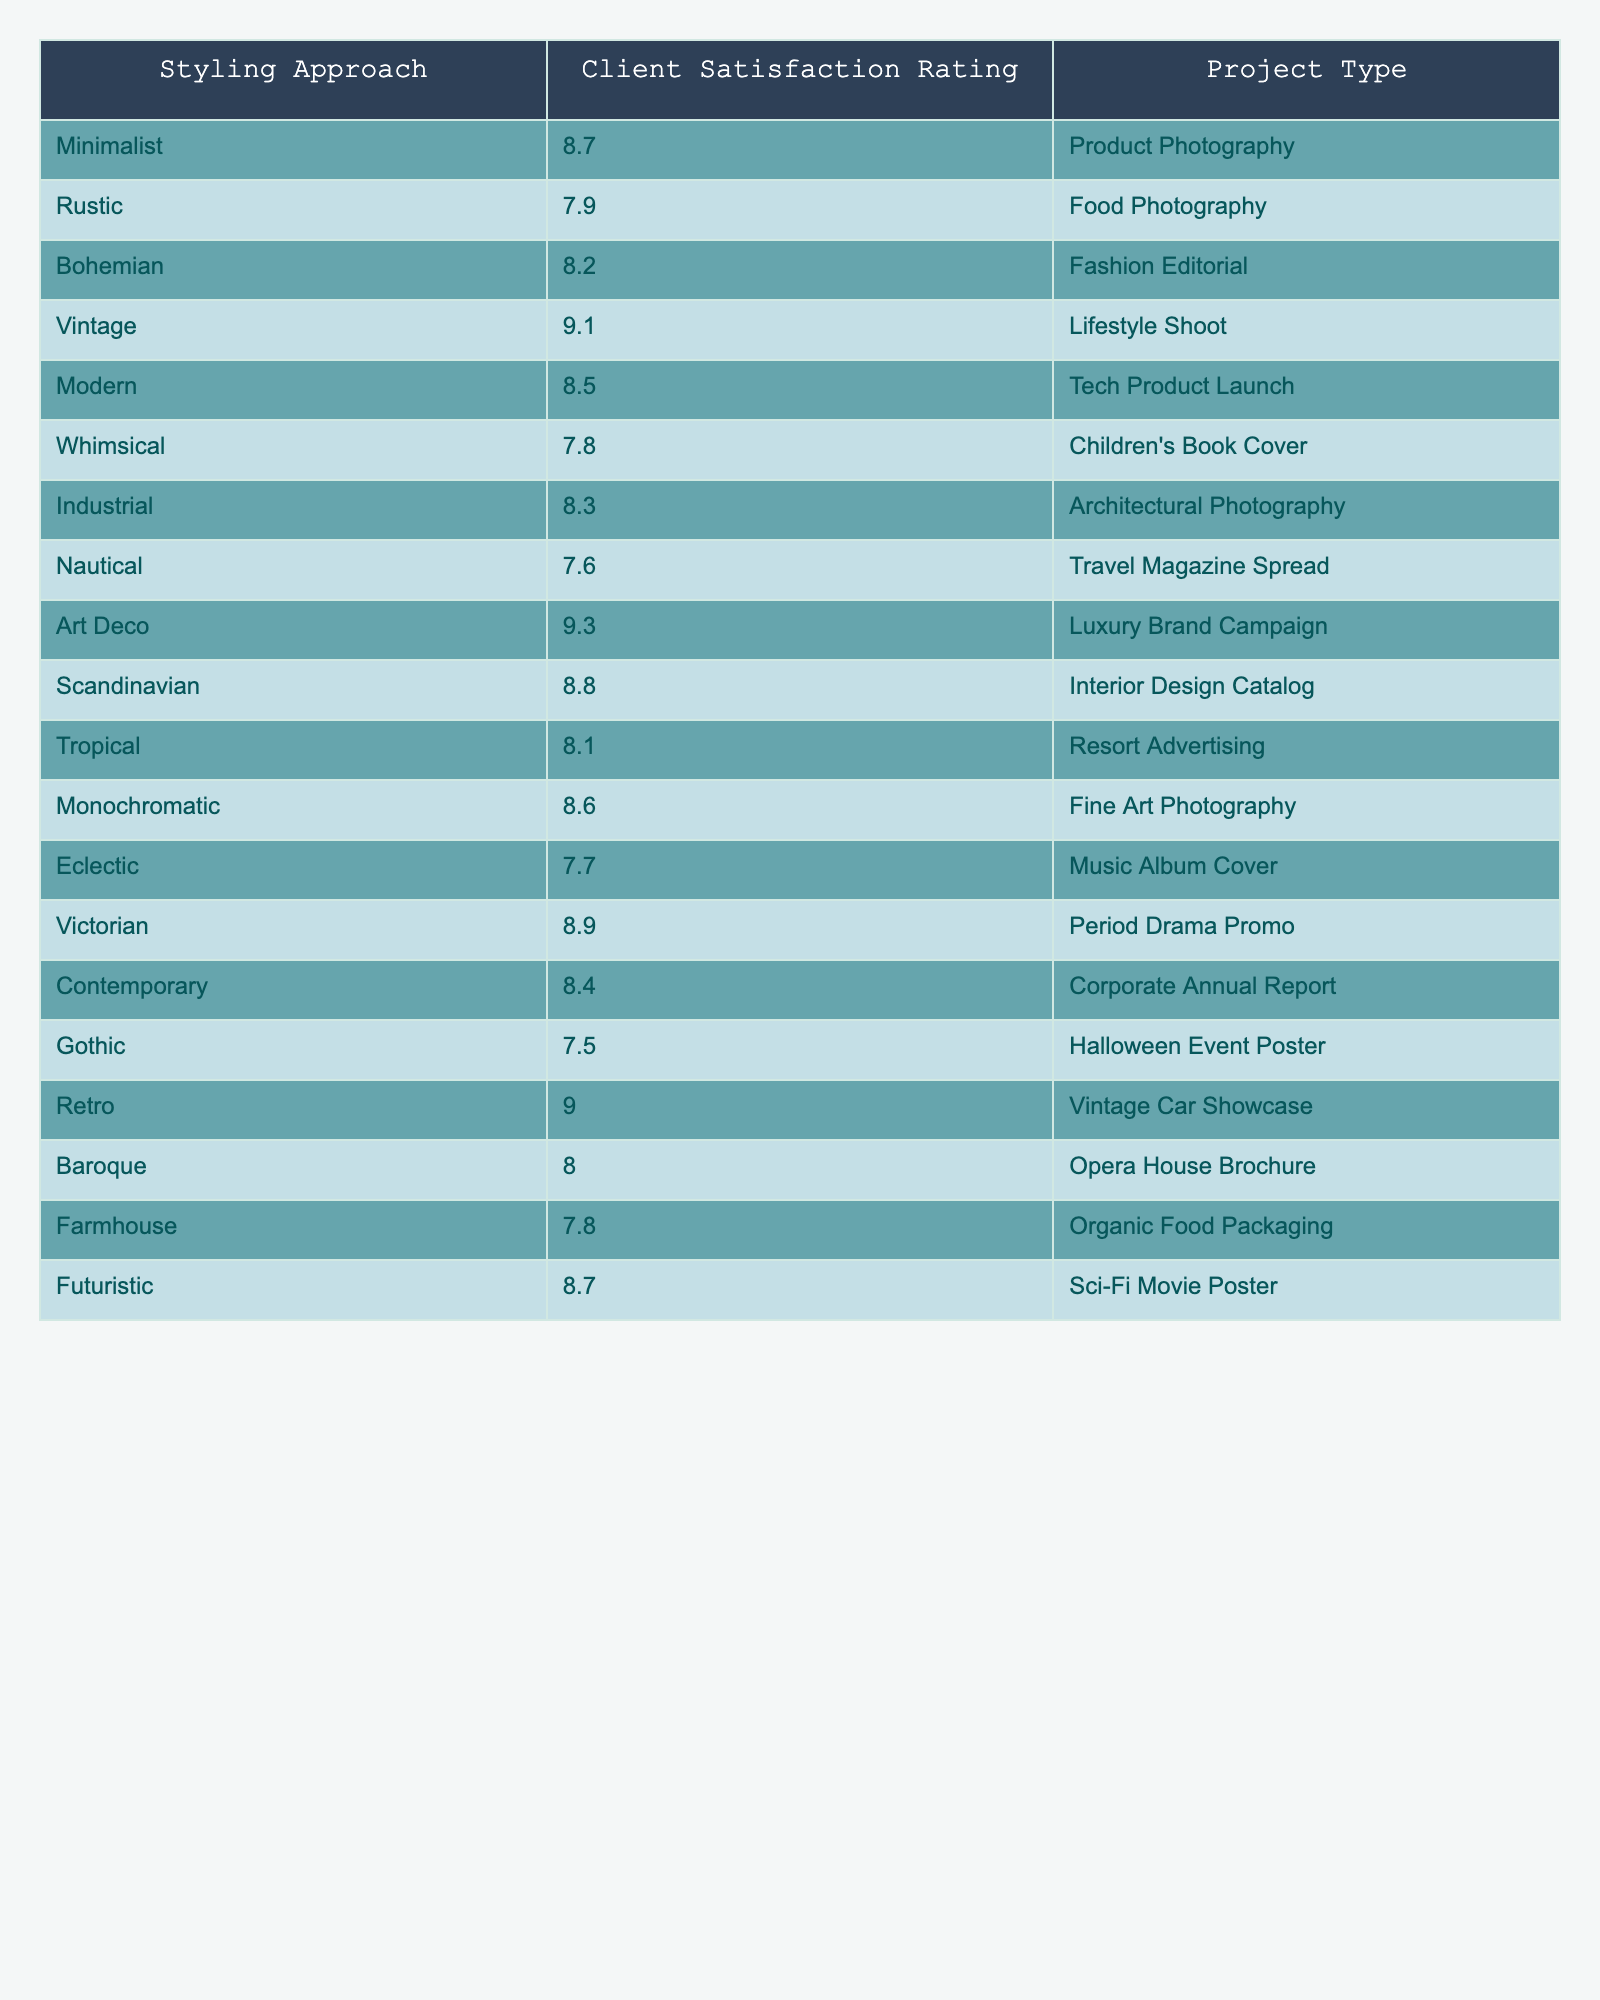What is the client satisfaction rating for the Vintage styling approach? The table shows that the client satisfaction rating for the Vintage approach is listed directly. According to the data, it is 9.1.
Answer: 9.1 Which styling approach has the lowest client satisfaction rating? By inspecting the ratings in the table, the Nautical approach has the lowest rating at 7.6 compared to other approaches.
Answer: Nautical What is the average client satisfaction rating for all styling approaches? First, we need to sum all the ratings. The total is 8.7 + 7.9 + 8.2 + 9.1 + 8.5 + 7.8 + 8.3 + 7.6 + 9.3 + 8.8 + 8.1 + 8.6 + 7.7 + 8.9 + 8.4 + 7.5 + 9.0 + 8.0 + 7.8 + 8.7, which equals 169.4. Next, we divide by the number of approaches, 20, to find the average: 169.4 / 20 = 8.47.
Answer: 8.47 Is the client satisfaction rating for Whimsical higher than for Industrial styling approaches? The Whimsical rating is 7.8 and the Industrial rating is 8.3. Since 7.8 is less than 8.3, Whimsical is not higher.
Answer: No What is the difference in client satisfaction ratings between the highest and lowest rated styling approaches? The highest rated approach is Art Deco at 9.3, and the lowest is Nautical at 7.6. To find the difference, we subtract the lowest from the highest: 9.3 - 7.6 = 1.7.
Answer: 1.7 How many styling approaches have a client satisfaction rating above 8.5? Checking the ratings, the following approaches exceed 8.5: Minimalist (8.7), Vintage (9.1), Art Deco (9.3), Scandinavian (8.8), Retro (9.0). Therefore, there are 5 approaches with ratings above 8.5.
Answer: 5 Which project type has the highest client satisfaction rating, and what is that rating? The highest rating in the table belongs to the Art Deco approach with 9.3, which corresponds to the Luxury Brand Campaign project type.
Answer: Art Deco; 9.3 Are there more styling approaches with ratings above 8 than below 8? The approaches with ratings above 8 are: Minimalist, Bohemian, Vintage, Modern, Art Deco, Scandinavian, Monochromatic, Victorian, Contemporary, Retro, bringing the total to 11. The below 8 ratings are Rustic, Whimsical, Industrial, Nautical, Eclectic, Gothic, Baroque, Farmhouse, which total 9. Since 11 is greater than 9, this is true.
Answer: Yes Which styling approach is preferred for Corporate Annual Report projects, and what is its rating? The Corporate Annual Report is associated with the Contemporary approach, which has a client satisfaction rating of 8.4 according to the table.
Answer: Contemporary; 8.4 What is the client satisfaction rating for the Tropical styling approach compared to the Scandinavian approach? The Tropical rating is 8.1 and the Scandinavian rating is 8.8. Since 8.1 is less than 8.8, the Tropical approach has a lower rating.
Answer: Lower 